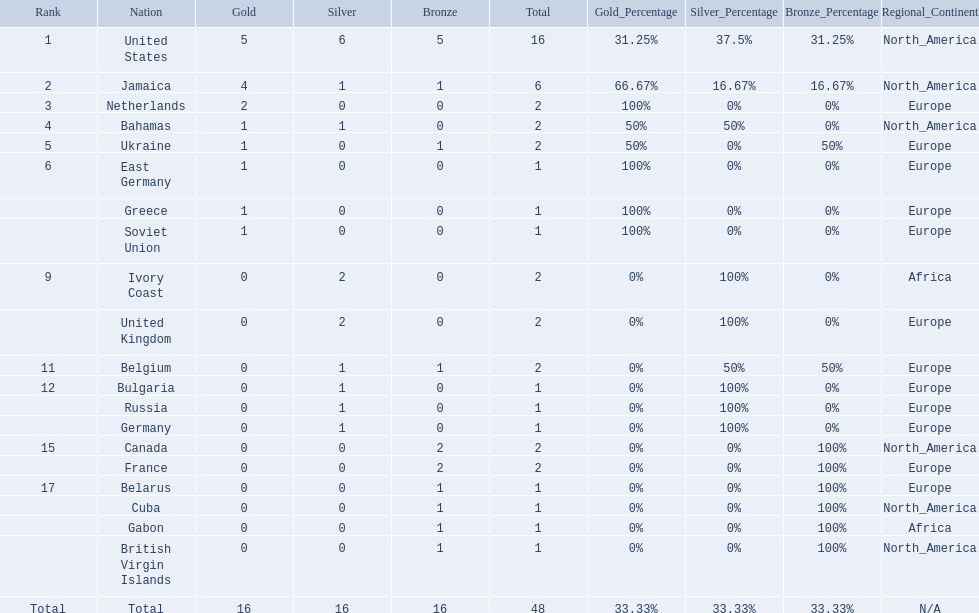What countries competed? United States, Jamaica, Netherlands, Bahamas, Ukraine, East Germany, Greece, Soviet Union, Ivory Coast, United Kingdom, Belgium, Bulgaria, Russia, Germany, Canada, France, Belarus, Cuba, Gabon, British Virgin Islands. Which countries won gold medals? United States, Jamaica, Netherlands, Bahamas, Ukraine, East Germany, Greece, Soviet Union. Which country had the second most medals? Jamaica. 